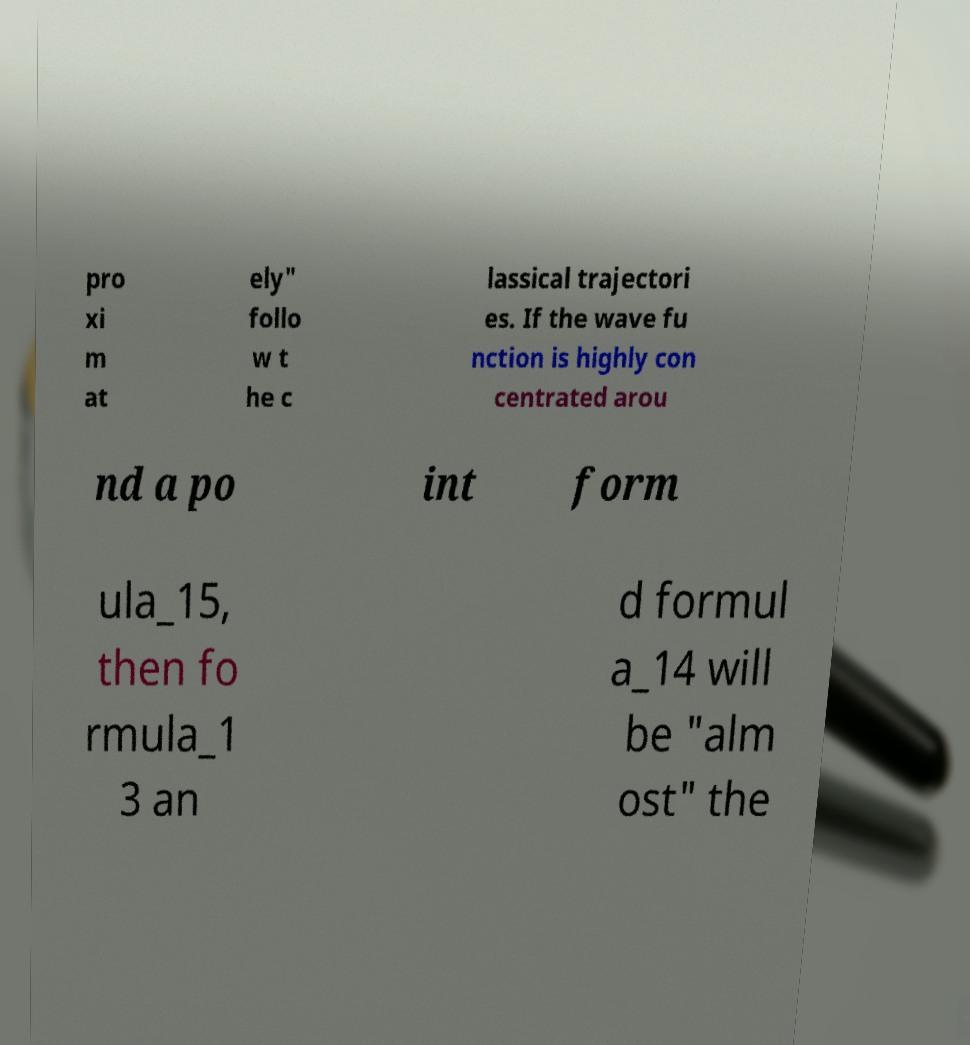Could you extract and type out the text from this image? pro xi m at ely" follo w t he c lassical trajectori es. If the wave fu nction is highly con centrated arou nd a po int form ula_15, then fo rmula_1 3 an d formul a_14 will be "alm ost" the 